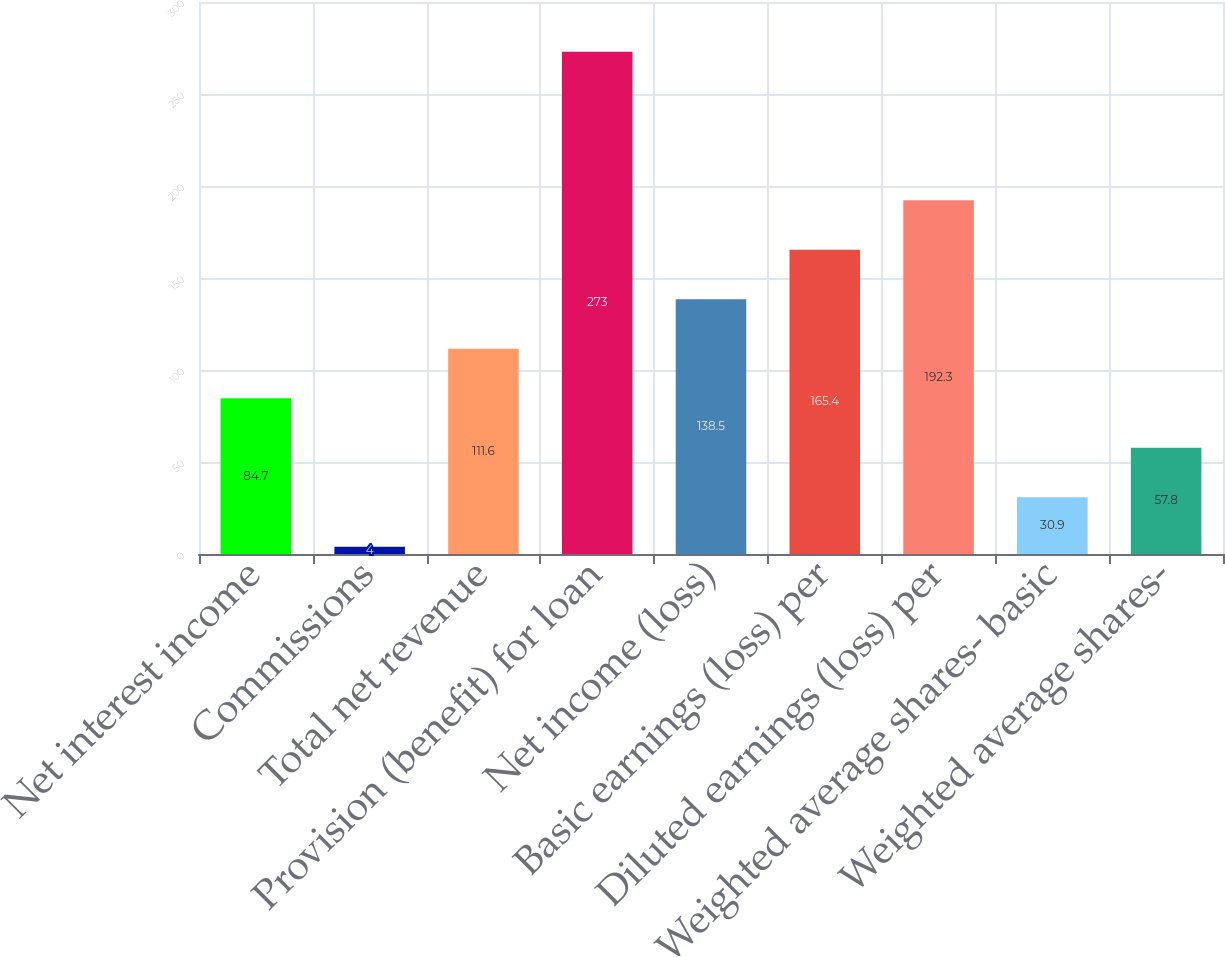<chart> <loc_0><loc_0><loc_500><loc_500><bar_chart><fcel>Net interest income<fcel>Commissions<fcel>Total net revenue<fcel>Provision (benefit) for loan<fcel>Net income (loss)<fcel>Basic earnings (loss) per<fcel>Diluted earnings (loss) per<fcel>Weighted average shares- basic<fcel>Weighted average shares-<nl><fcel>84.7<fcel>4<fcel>111.6<fcel>273<fcel>138.5<fcel>165.4<fcel>192.3<fcel>30.9<fcel>57.8<nl></chart> 